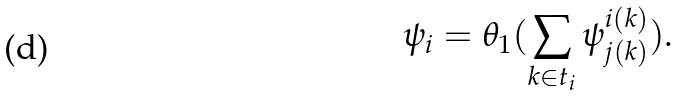Convert formula to latex. <formula><loc_0><loc_0><loc_500><loc_500>\psi _ { i } = \theta _ { 1 } ( \sum _ { k \in t _ { i } } \psi _ { j ( k ) } ^ { i ( k ) } ) .</formula> 